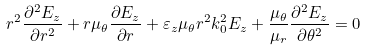Convert formula to latex. <formula><loc_0><loc_0><loc_500><loc_500>r ^ { 2 } \frac { \partial ^ { 2 } E _ { z } } { \partial r ^ { 2 } } + r \mu _ { \theta } \frac { \partial E _ { z } } { \partial r } + \varepsilon _ { z } \mu _ { \theta } r ^ { 2 } k _ { 0 } ^ { 2 } E _ { z } + \frac { \mu _ { \theta } } { \mu _ { r } } \frac { \partial ^ { 2 } E _ { z } } { \partial \theta ^ { 2 } } = 0</formula> 